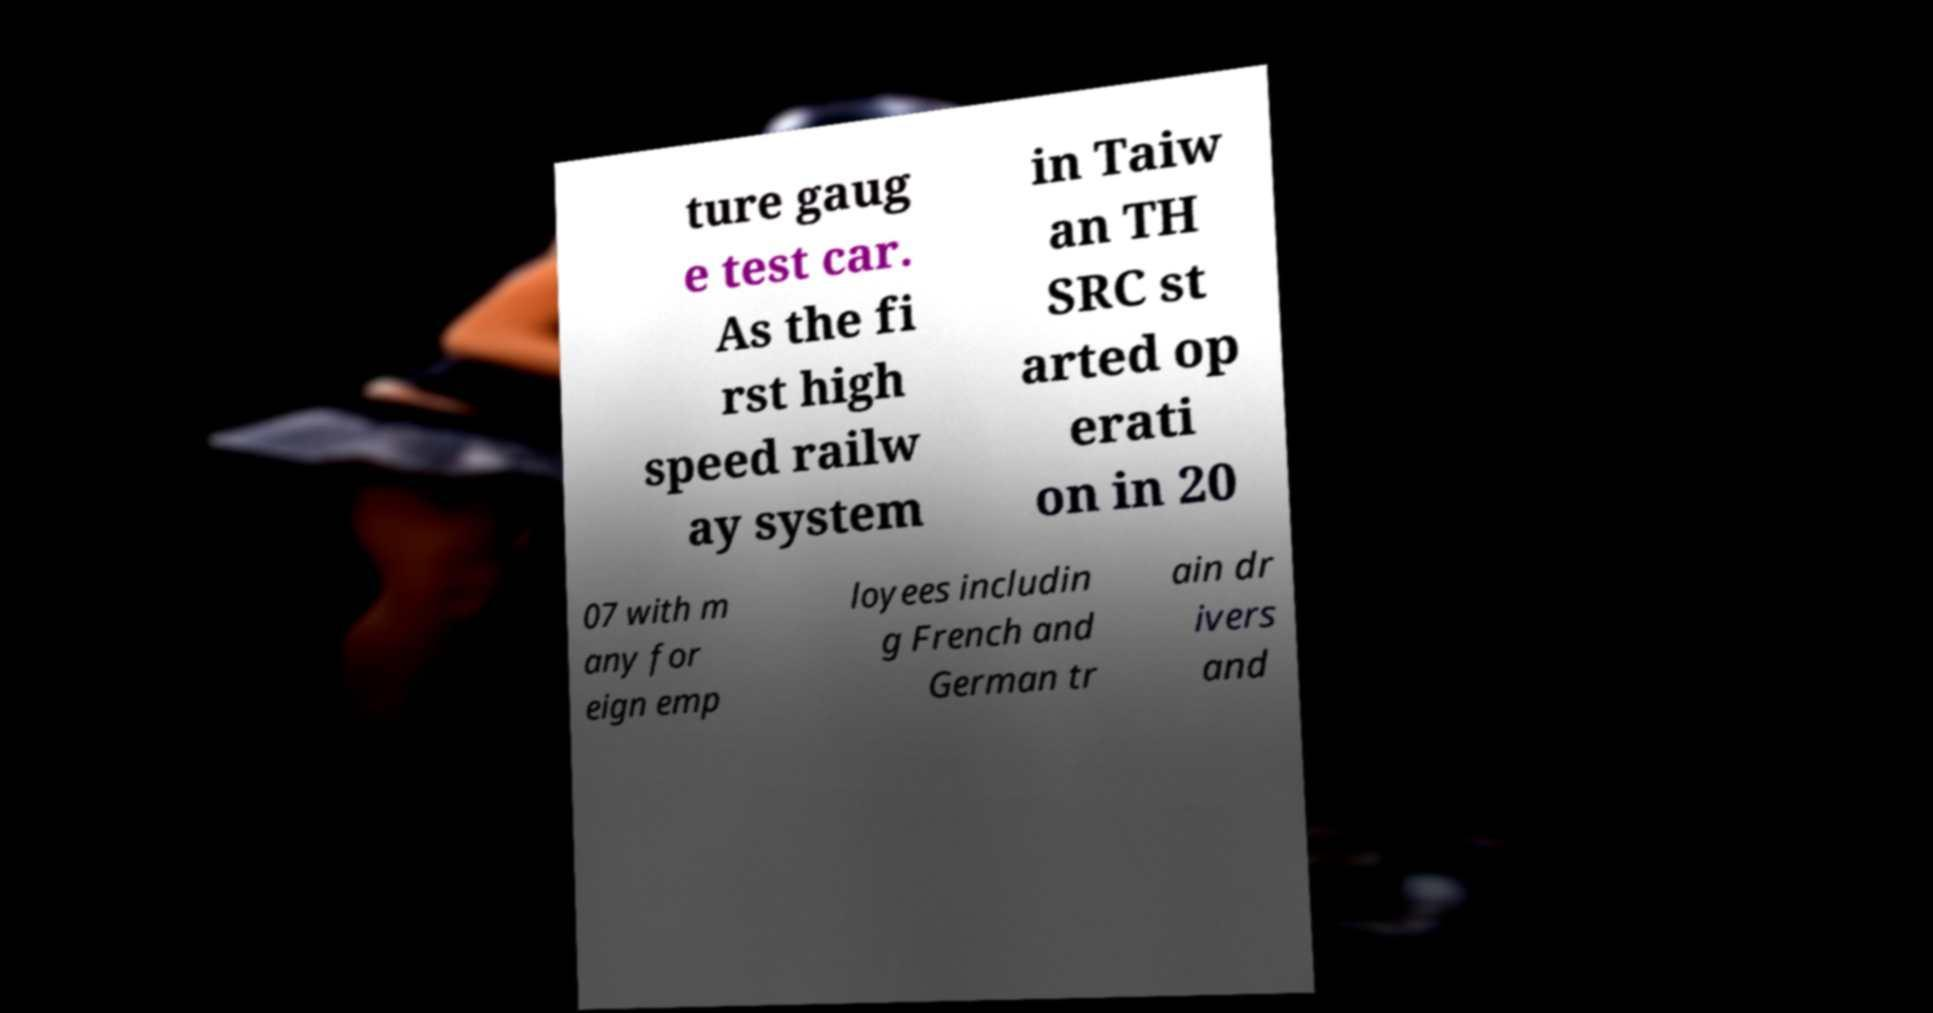Can you read and provide the text displayed in the image?This photo seems to have some interesting text. Can you extract and type it out for me? ture gaug e test car. As the fi rst high speed railw ay system in Taiw an TH SRC st arted op erati on in 20 07 with m any for eign emp loyees includin g French and German tr ain dr ivers and 